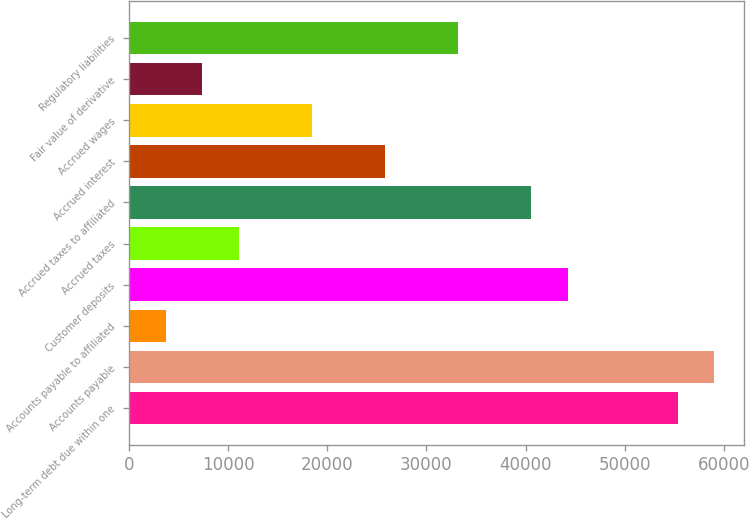Convert chart. <chart><loc_0><loc_0><loc_500><loc_500><bar_chart><fcel>Long-term debt due within one<fcel>Accounts payable<fcel>Accounts payable to affiliated<fcel>Customer deposits<fcel>Accrued taxes<fcel>Accrued taxes to affiliated<fcel>Accrued interest<fcel>Accrued wages<fcel>Fair value of derivative<fcel>Regulatory liabilities<nl><fcel>55326.5<fcel>59014.8<fcel>3690.3<fcel>44261.6<fcel>11066.9<fcel>40573.3<fcel>25820.1<fcel>18443.5<fcel>7378.6<fcel>33196.7<nl></chart> 